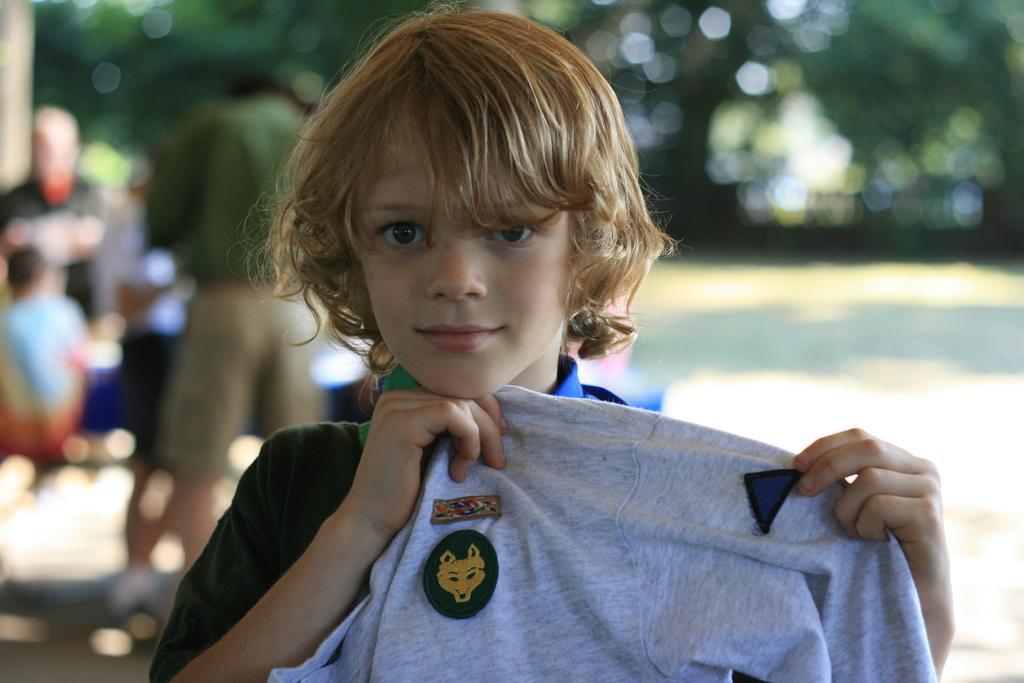Describe this image in one or two sentences. In this picture we can see a kid holding a cloth here, in the background there are some people standing here, we can also see trees in the background. 